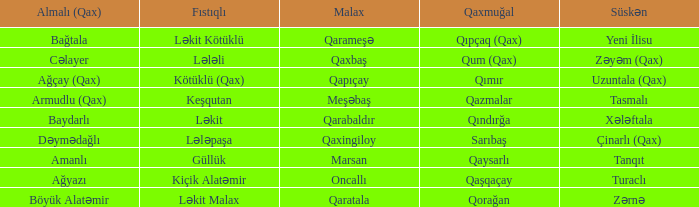What is the Qaxmuğal village with a Fistiqli village keşqutan? Qazmalar. 